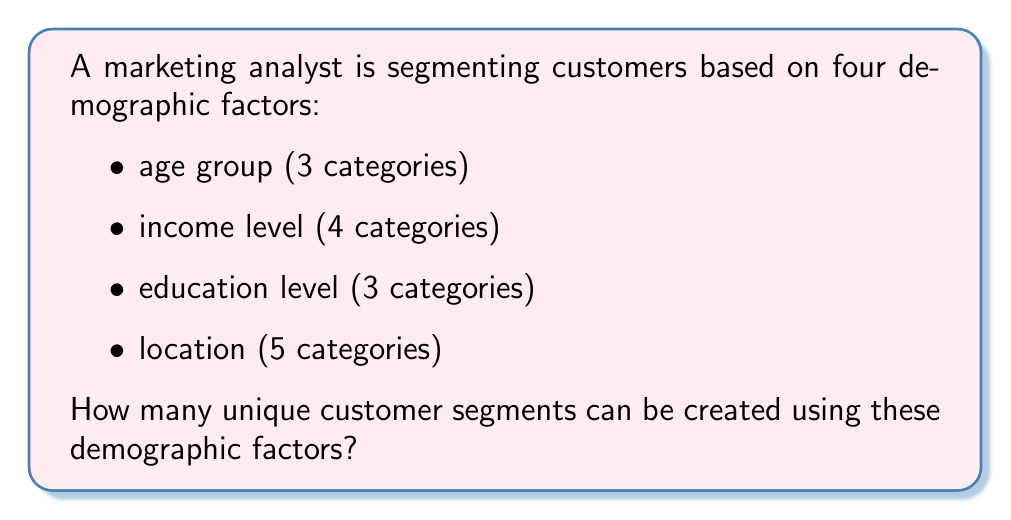Give your solution to this math problem. To solve this problem, we'll use the multiplication principle of combinatorics. Here's the step-by-step solution:

1. Identify the number of options for each demographic factor:
   - Age group: 3 categories
   - Income level: 4 categories
   - Education level: 3 categories
   - Location: 5 categories

2. Apply the multiplication principle:
   The total number of unique combinations is the product of the number of options for each factor.

   $$ \text{Total combinations} = 3 \times 4 \times 3 \times 5 $$

3. Calculate the result:
   $$ \text{Total combinations} = 3 \times 4 \times 3 \times 5 = 180 $$

Each unique combination represents a distinct customer segment based on these demographic factors.
Answer: 180 unique segments 